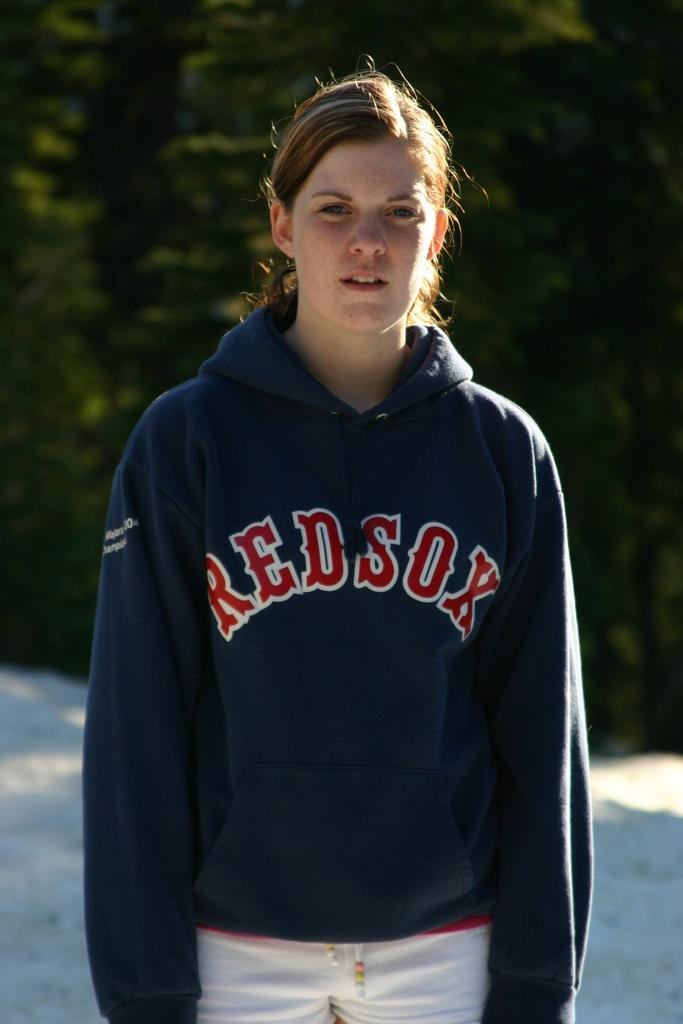<image>
Describe the image concisely. a girl proudly wearing a navy Boston Red Sox sweatshirt 